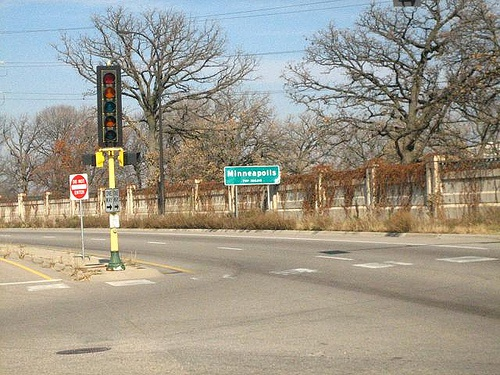Describe the objects in this image and their specific colors. I can see traffic light in lightblue, black, gray, and maroon tones, traffic light in lightblue, gray, black, and darkgreen tones, and traffic light in lightblue, gray, darkgreen, and black tones in this image. 